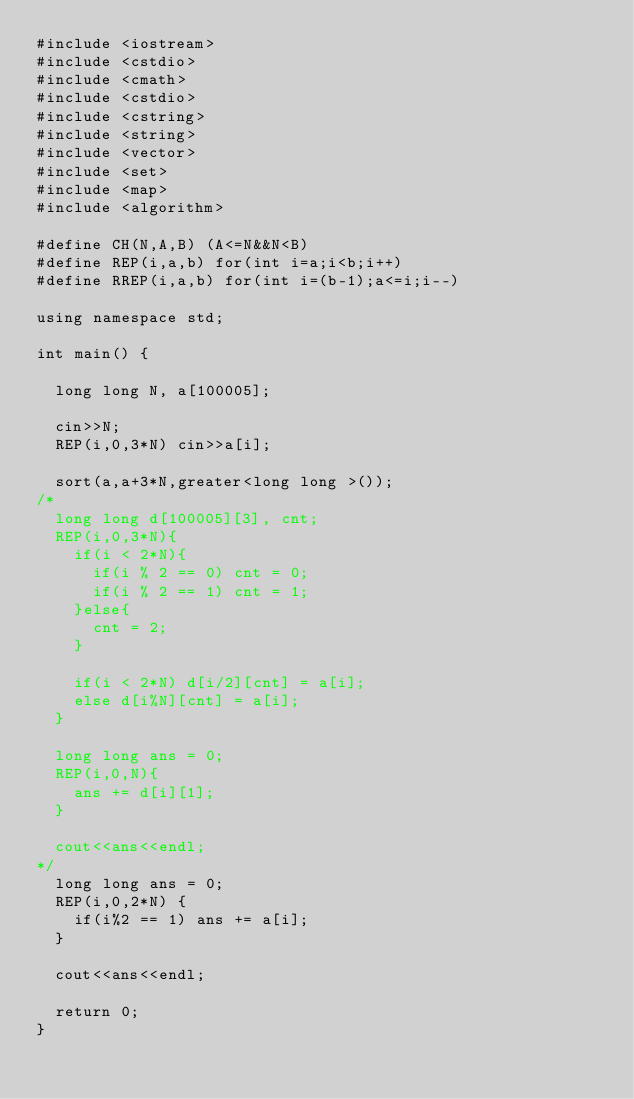Convert code to text. <code><loc_0><loc_0><loc_500><loc_500><_C++_>#include <iostream>
#include <cstdio>
#include <cmath>
#include <cstdio>
#include <cstring>
#include <string>
#include <vector>
#include <set>
#include <map>
#include <algorithm>

#define CH(N,A,B) (A<=N&&N<B)
#define REP(i,a,b) for(int i=a;i<b;i++)
#define RREP(i,a,b) for(int i=(b-1);a<=i;i--)

using namespace std;

int main() {

  long long N, a[100005];

  cin>>N;
  REP(i,0,3*N) cin>>a[i];

  sort(a,a+3*N,greater<long long >());
/*
  long long d[100005][3], cnt;
  REP(i,0,3*N){
    if(i < 2*N){
      if(i % 2 == 0) cnt = 0;
      if(i % 2 == 1) cnt = 1;
    }else{
      cnt = 2;
    }

    if(i < 2*N) d[i/2][cnt] = a[i];
    else d[i%N][cnt] = a[i];
  }

  long long ans = 0;
  REP(i,0,N){
    ans += d[i][1];
  }

  cout<<ans<<endl;
*/
  long long ans = 0;
  REP(i,0,2*N) {
    if(i%2 == 1) ans += a[i];
  }

  cout<<ans<<endl;

  return 0;
}
</code> 